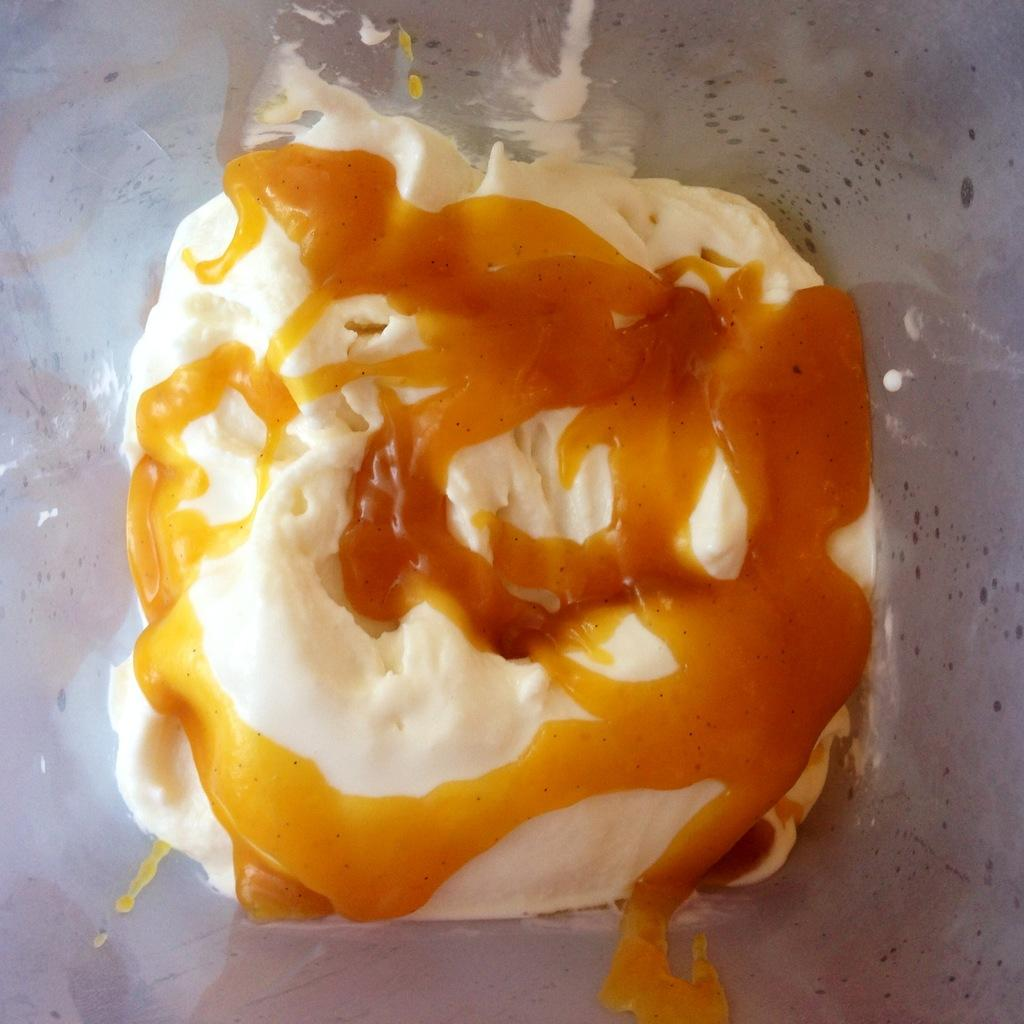What is the main subject of the image? The main subject of the image is a mixture of cream and honey. How is the mixture presented in the image? The mixture is kept on a plate. What type of waves can be seen crashing on the shore in the image? There are no waves present in the image; it features a mixture of cream and honey on a plate. 